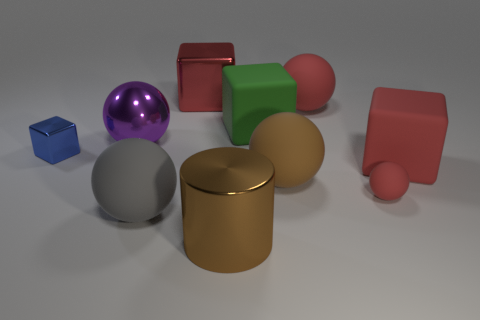How many red spheres must be subtracted to get 1 red spheres? 1 Subtract all cubes. How many objects are left? 6 Subtract all tiny metal things. Subtract all blue metal blocks. How many objects are left? 8 Add 8 big green matte cubes. How many big green matte cubes are left? 9 Add 6 big purple objects. How many big purple objects exist? 7 Subtract all green cubes. How many cubes are left? 3 Subtract all large cubes. How many cubes are left? 1 Subtract 0 yellow spheres. How many objects are left? 10 Subtract 4 blocks. How many blocks are left? 0 Subtract all gray spheres. Subtract all gray blocks. How many spheres are left? 4 